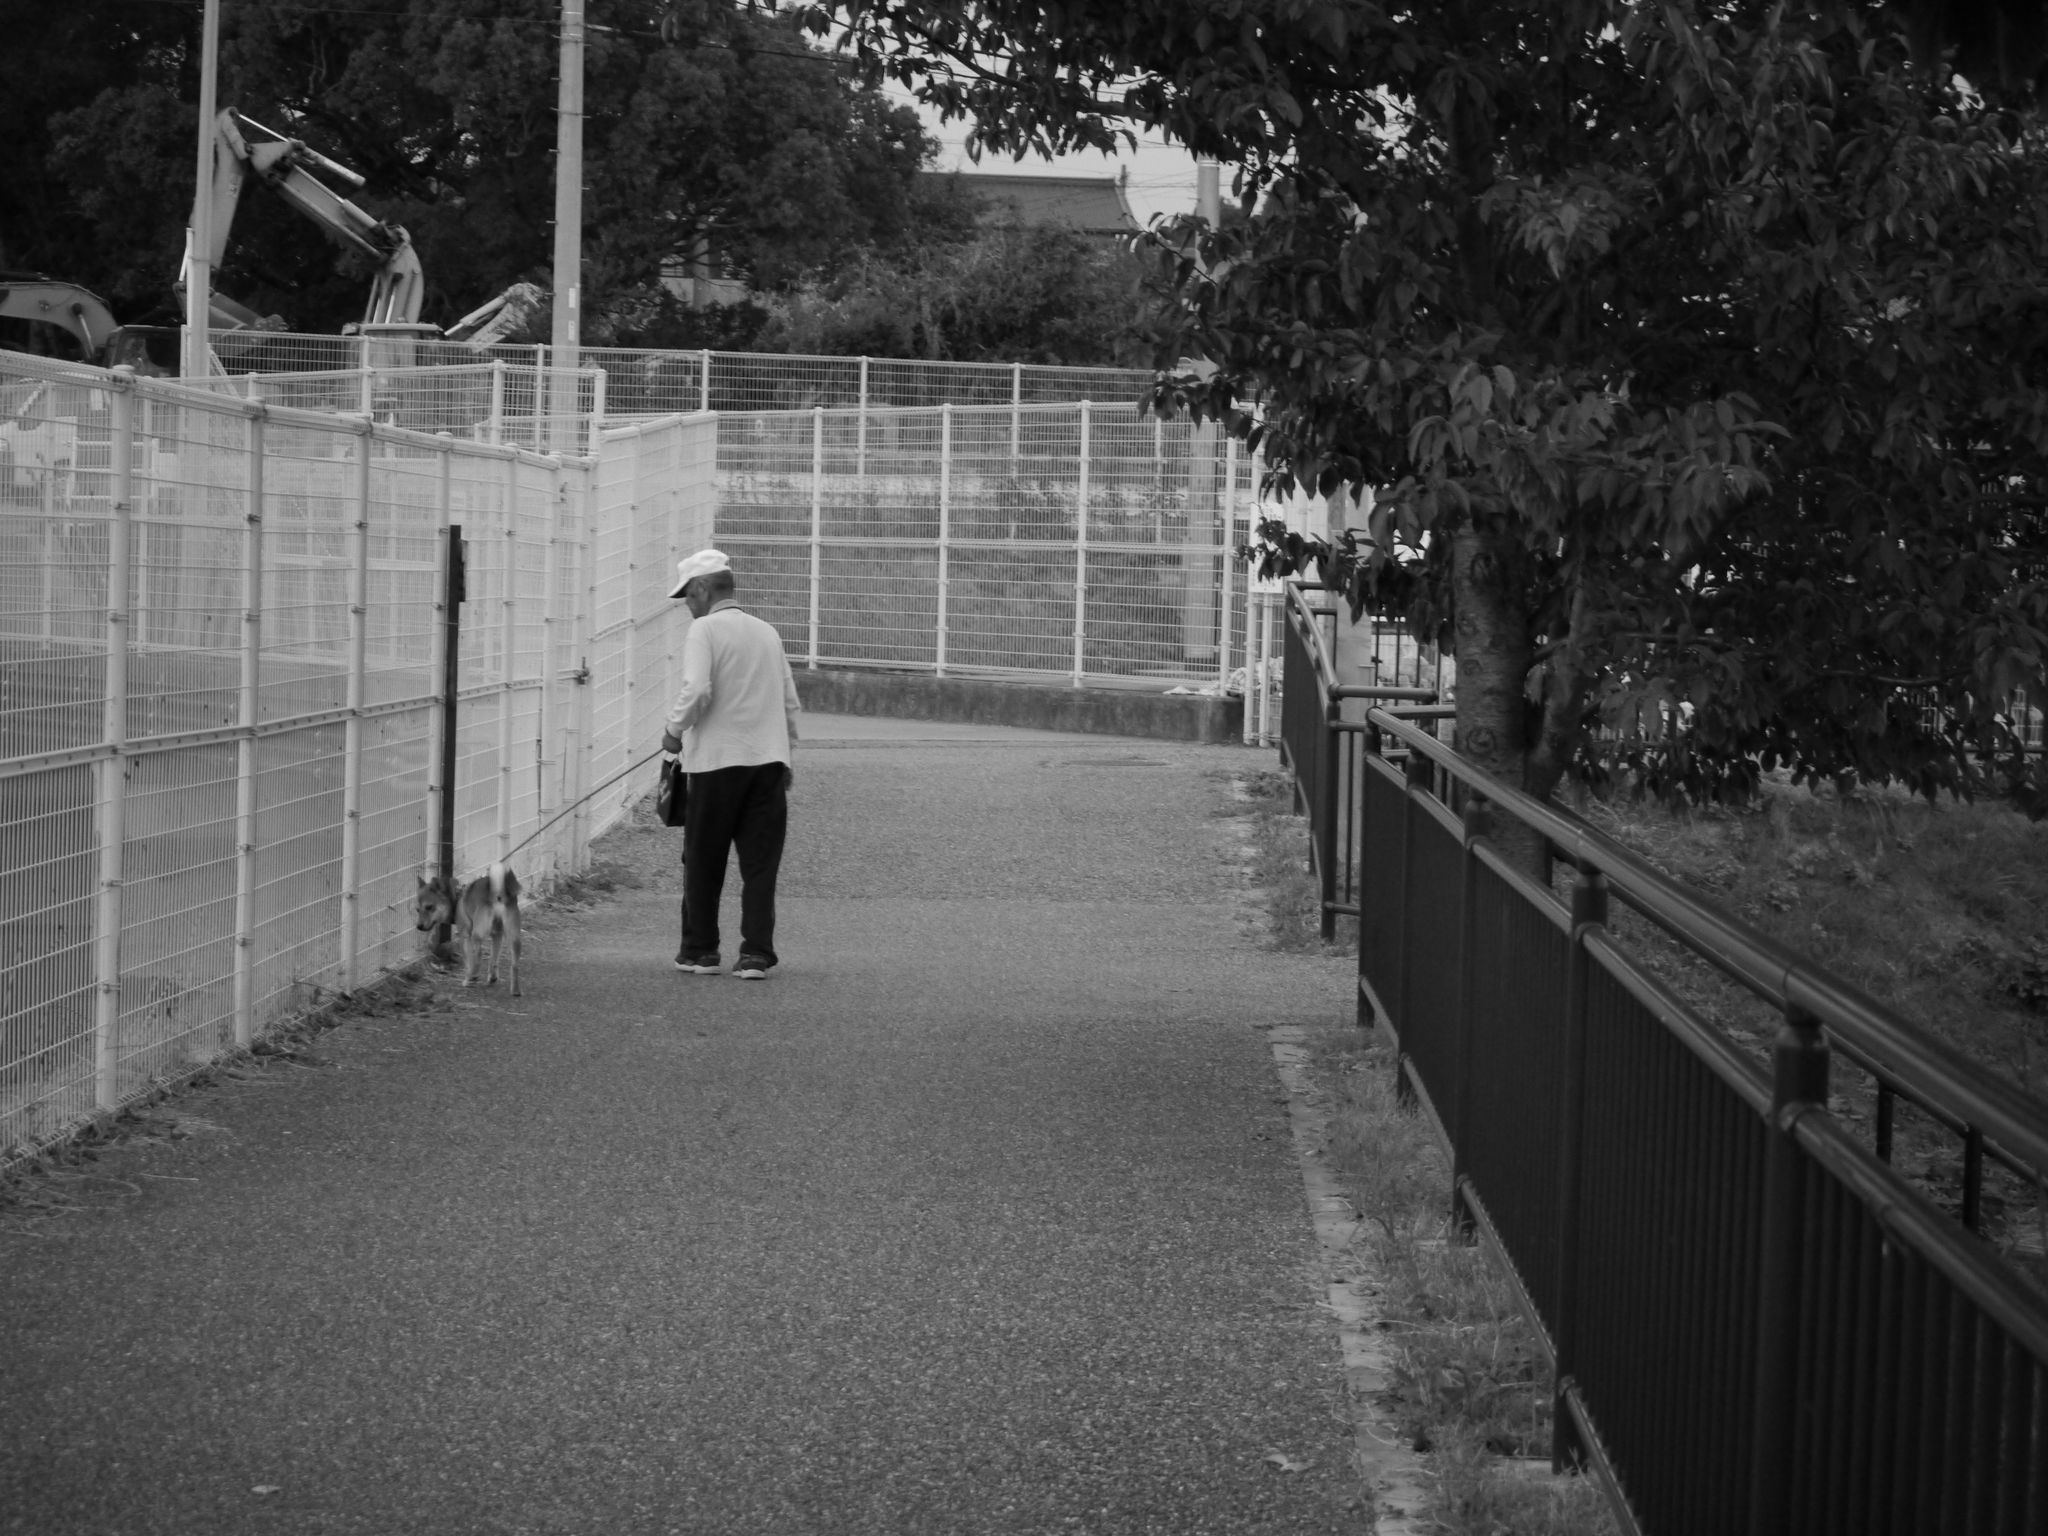How would you summarize this image in a sentence or two? In this picture we can see a person, the person wore a cap, beside to the person we can find a dog and it is tied with a belt, in front of the person we can find fences, trees, vehicles and a house. 